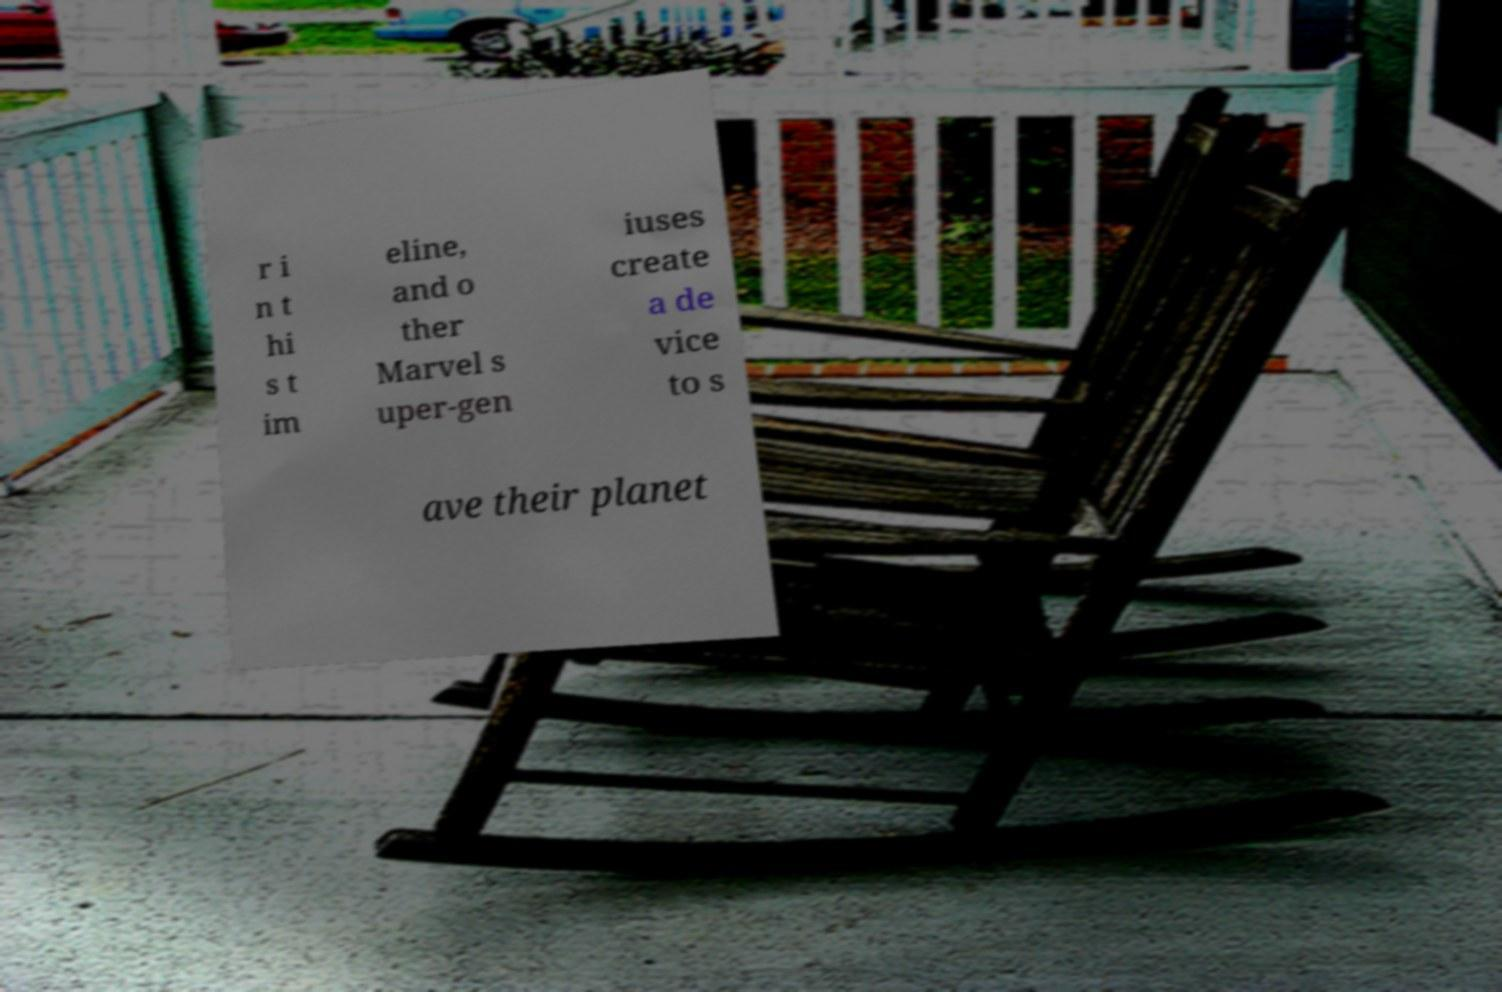Can you accurately transcribe the text from the provided image for me? r i n t hi s t im eline, and o ther Marvel s uper-gen iuses create a de vice to s ave their planet 